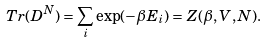Convert formula to latex. <formula><loc_0><loc_0><loc_500><loc_500>T r ( D ^ { N } ) = \sum _ { i } \exp ( - \beta E _ { i } ) = Z ( \beta , V , N ) .</formula> 